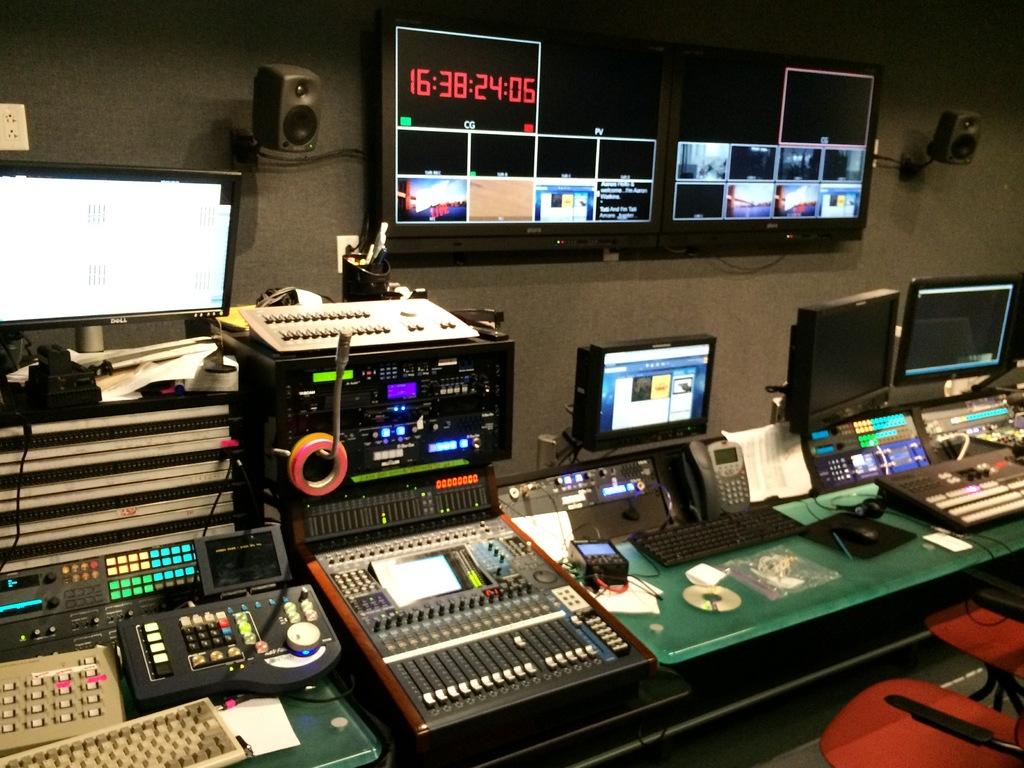What is the time displayed on the tv in red?
Make the answer very short. 16:38:24:06. 